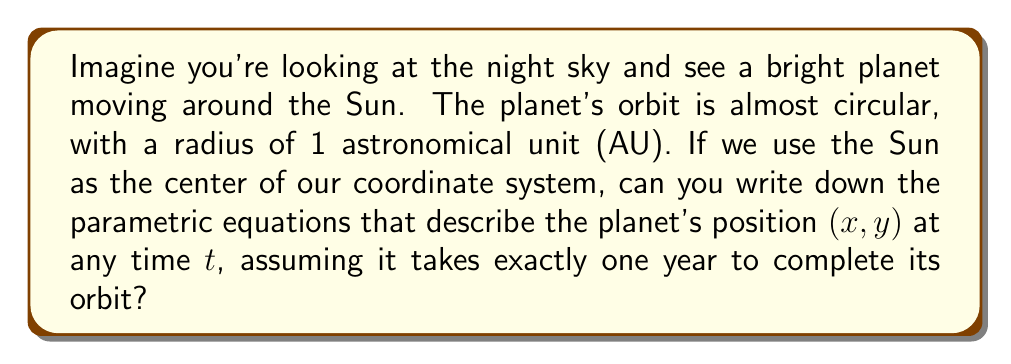Teach me how to tackle this problem. Let's break this down step-by-step:

1) First, we need to understand what parametric equations are. They're a way to describe a curve using a parameter (in this case, time $t$).

2) For a circular orbit, we can use sine and cosine functions to describe the $x$ and $y$ coordinates:

   $x = r \cos(\theta)$
   $y = r \sin(\theta)$

   Where $r$ is the radius of the orbit, and $\theta$ is the angle from the x-axis.

3) In this case, $r = 1$ AU (given in the question).

4) Now, we need to relate $\theta$ to time $t$. We know the planet completes one full orbit (360° or $2\pi$ radians) in one year.

5) If we measure $t$ in years, then:

   $\theta = 2\pi t$

6) Substituting this into our equations:

   $x = \cos(2\pi t)$
   $y = \sin(2\pi t)$

7) These are our parametric equations! As $t$ goes from 0 to 1, the planet completes one full orbit.

[asy]
import graph;
size(200);
real xmin=-1.2, xmax=1.2, ymin=-1.2, ymax=1.2;
draw((xmin,0)--(xmax,0),Arrow);
draw((0,ymin)--(0,ymax),Arrow);
real t;
path p;
for(t=0; t<=1; t+=0.01) {
  p=p--(cos(2*pi*t),sin(2*pi*t));
}
draw(p,red);
dot((0,0),black);
label("Sun",(0,0),SW);
dot((1,0),blue);
label("Planet at t=0",(1,0),E);
[/asy]
Answer: The parametric equations describing the planet's orbit are:

$$\begin{aligned}
x &= \cos(2\pi t) \\
y &= \sin(2\pi t)
\end{aligned}$$

Where $t$ is measured in years. 